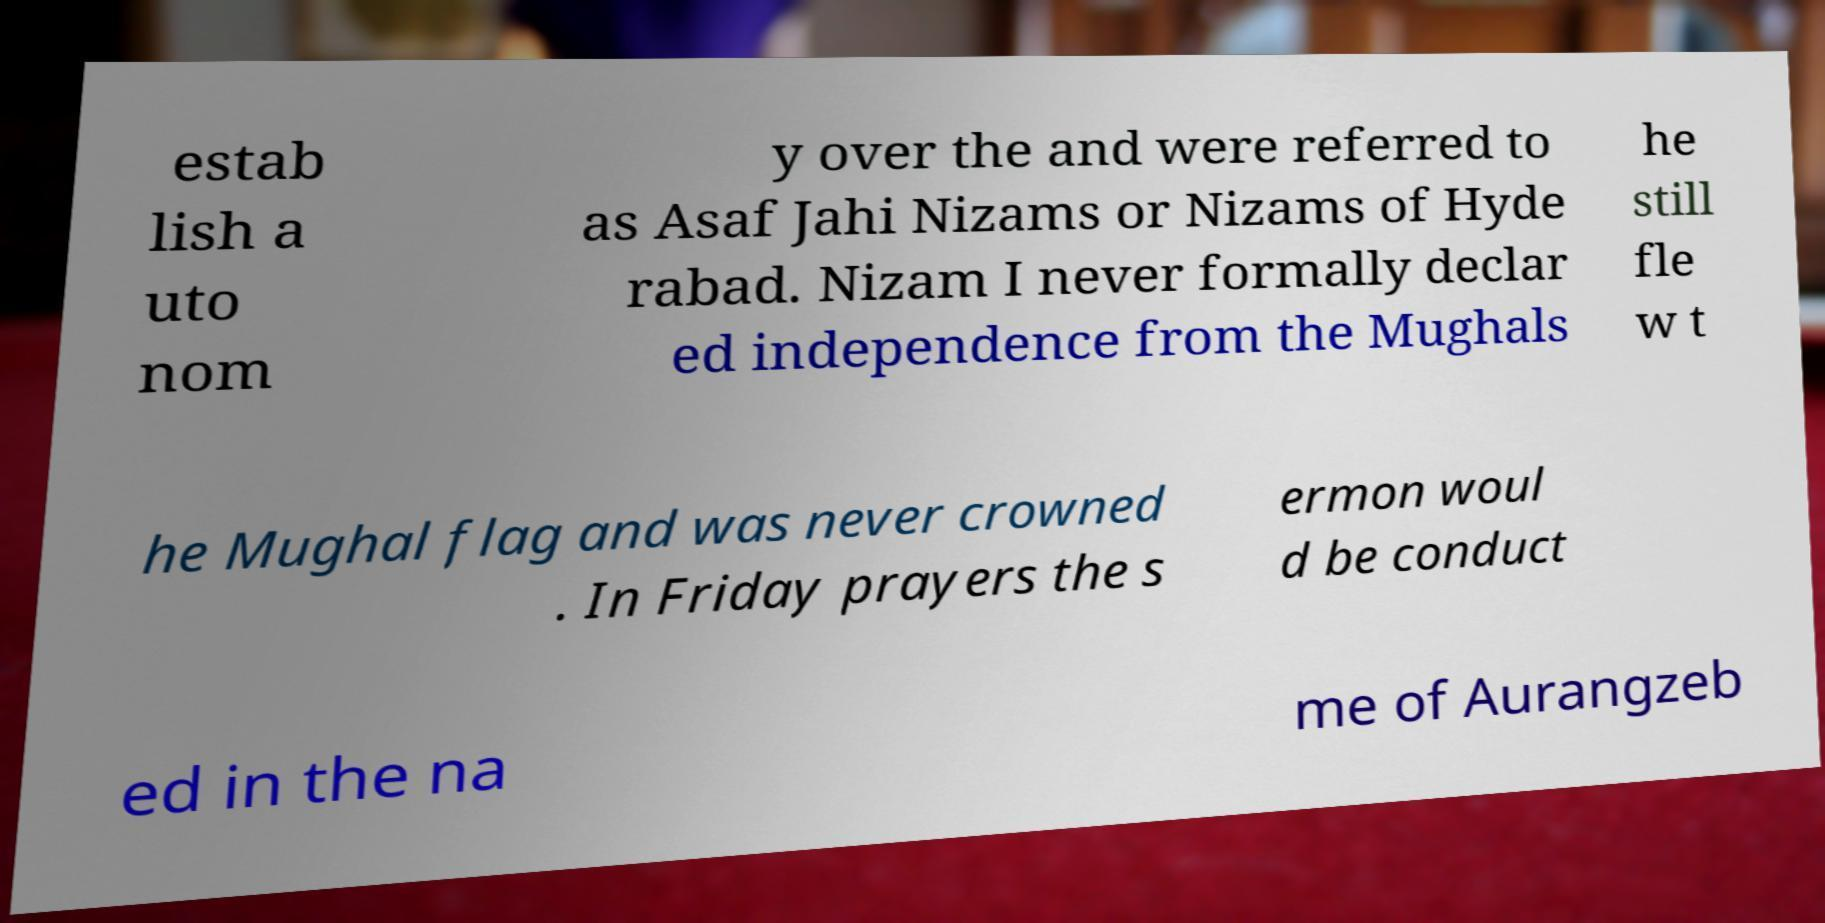Could you extract and type out the text from this image? estab lish a uto nom y over the and were referred to as Asaf Jahi Nizams or Nizams of Hyde rabad. Nizam I never formally declar ed independence from the Mughals he still fle w t he Mughal flag and was never crowned . In Friday prayers the s ermon woul d be conduct ed in the na me of Aurangzeb 